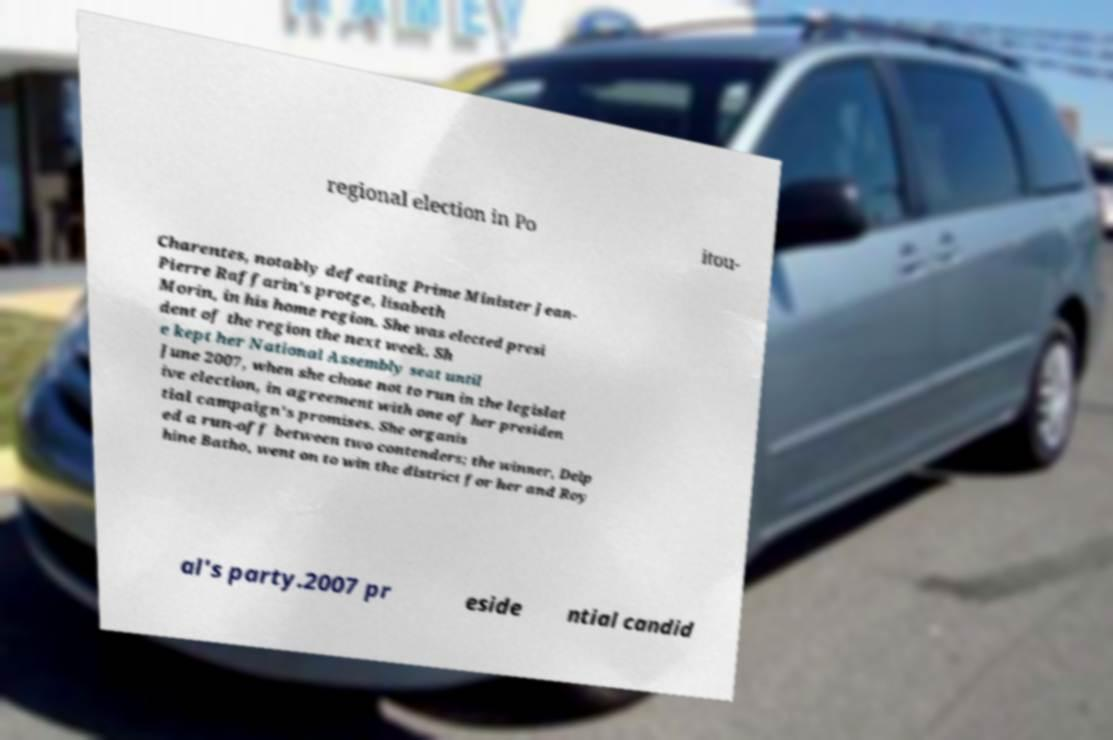Please identify and transcribe the text found in this image. regional election in Po itou- Charentes, notably defeating Prime Minister Jean- Pierre Raffarin's protge, lisabeth Morin, in his home region. She was elected presi dent of the region the next week. Sh e kept her National Assembly seat until June 2007, when she chose not to run in the legislat ive election, in agreement with one of her presiden tial campaign's promises. She organis ed a run-off between two contenders; the winner, Delp hine Batho, went on to win the district for her and Roy al's party.2007 pr eside ntial candid 